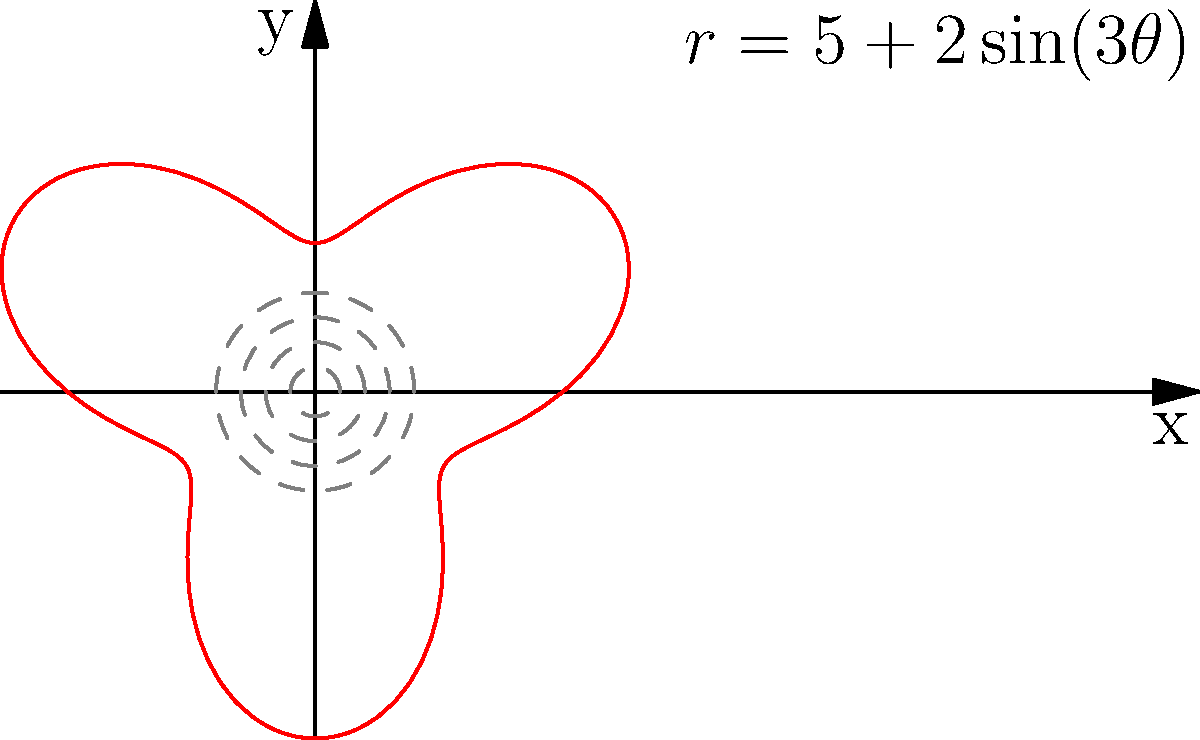In a thrilling Quidditch match, Harry Potter notices that the Golden Snitch is following an unusual trajectory. As a creative fanfiction writer, you decide to represent this trajectory using the polar equation $r = 5 + 2\sin(3\theta)$. At which angle $\theta$ (in radians) does the Snitch reach its maximum distance from the origin? To find the maximum distance of the Snitch from the origin, we need to determine where $r$ is at its maximum value. Let's approach this step-by-step:

1) The equation given is $r = 5 + 2\sin(3\theta)$

2) The maximum value of sine is 1, which occurs when its argument is $\frac{\pi}{2}$ or odd multiples of $\frac{\pi}{2}$.

3) So, we need to solve: $3\theta = \frac{\pi}{2}$ (or odd multiples of $\frac{\pi}{2}$)

4) Solving for $\theta$:
   $\theta = \frac{\pi}{6}$ (or odd multiples of $\frac{\pi}{6}$)

5) The first positive solution in the range $[0, 2\pi]$ is $\theta = \frac{\pi}{6}$.

6) We can verify that this gives us the maximum $r$ value:
   $r = 5 + 2\sin(3 \cdot \frac{\pi}{6}) = 5 + 2\sin(\frac{\pi}{2}) = 5 + 2 = 7$

Therefore, the Snitch reaches its maximum distance from the origin at $\theta = \frac{\pi}{6}$ radians.
Answer: $\frac{\pi}{6}$ radians 